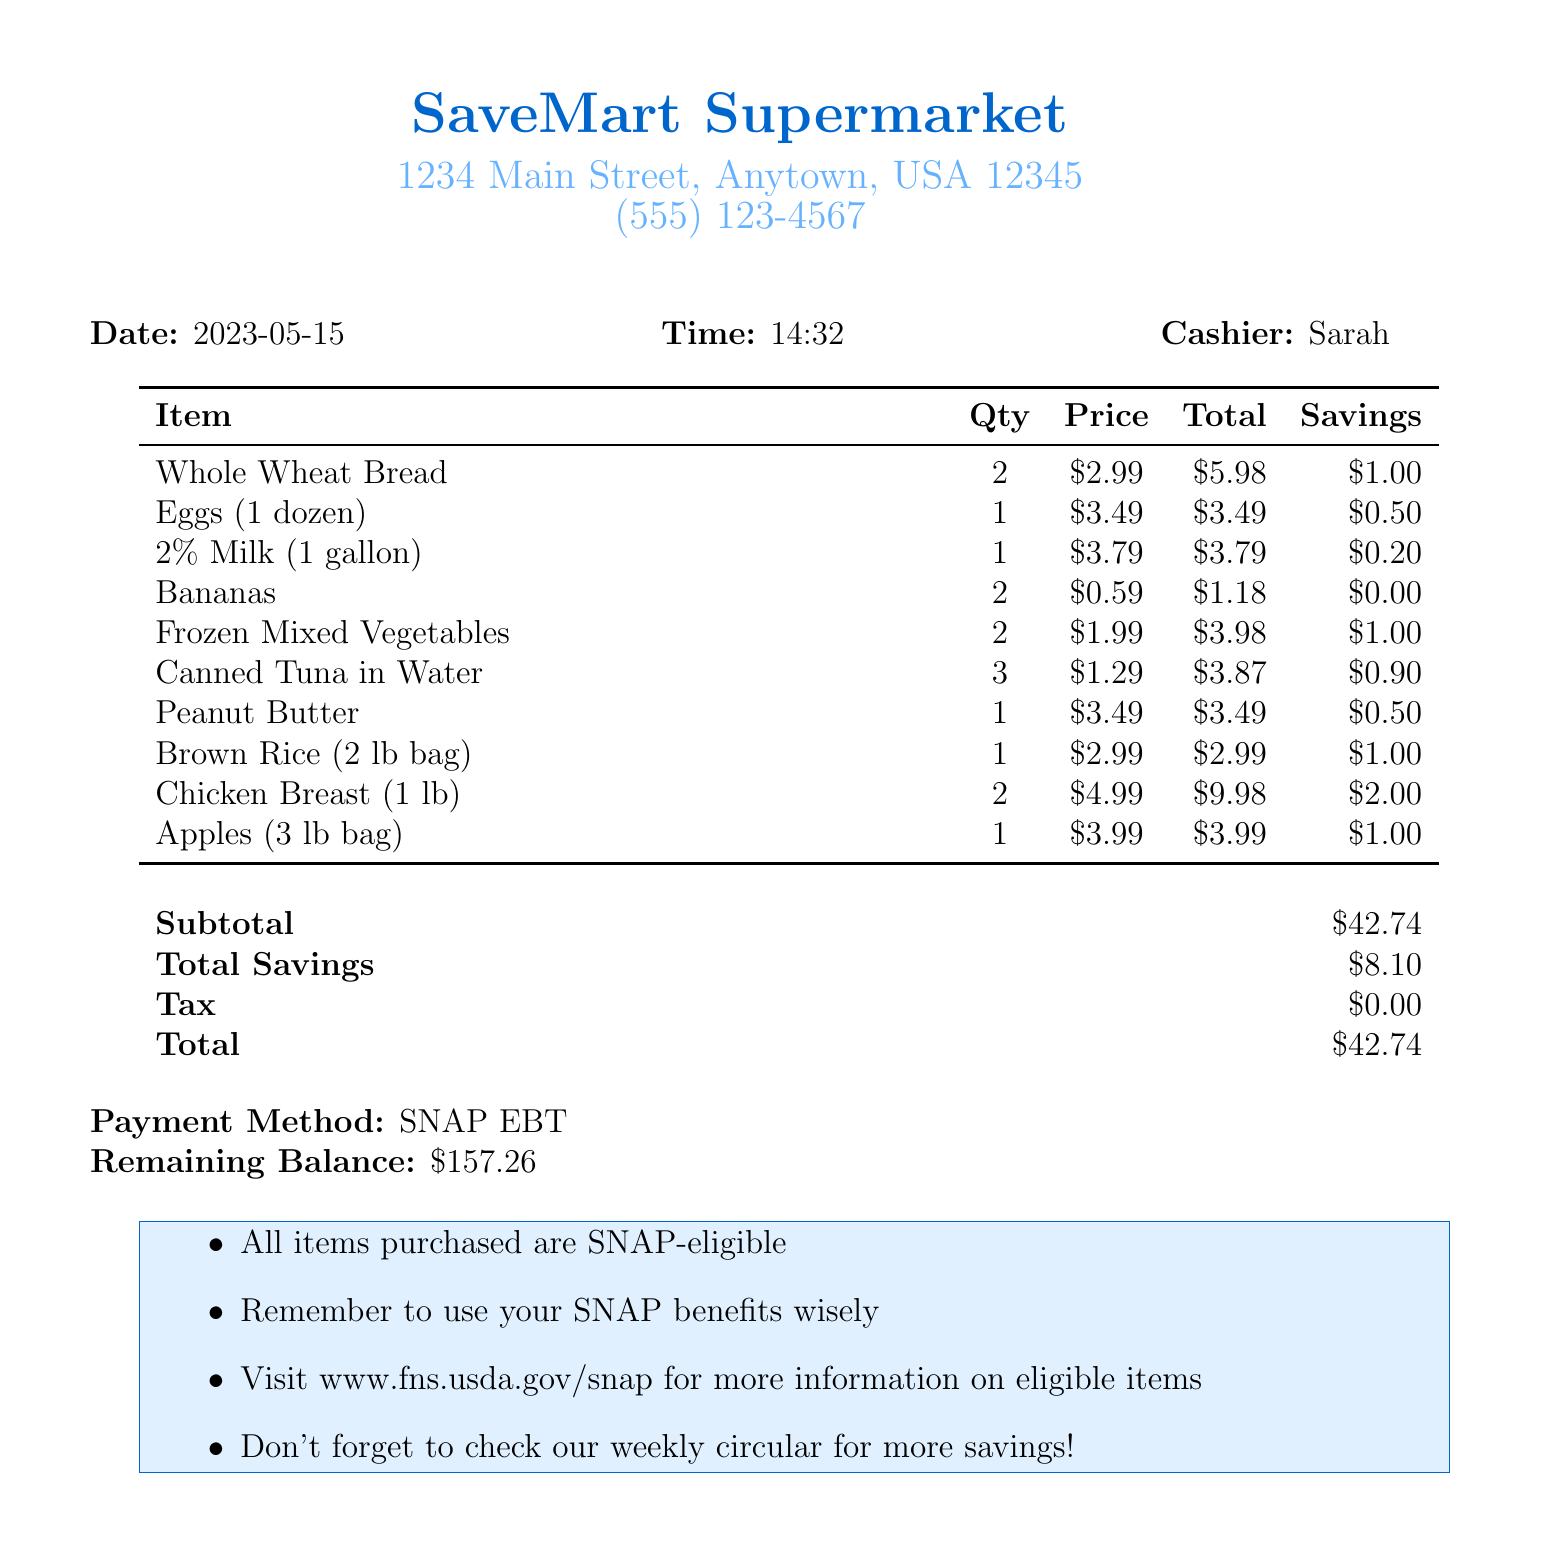What is the name of the store? The name of the store is listed at the top of the invoice.
Answer: SaveMart Supermarket What is the total price of the groceries? The total price is mentioned at the end of the invoice in a specific section.
Answer: $42.74 How much did you save in total? The total savings is detailed towards the end of the invoice.
Answer: $8.10 How many Chicken Breasts did you purchase? The quantity purchased is specified in the itemized list.
Answer: 2 What is the payment method used? The payment method is clearly stated near the bottom of the invoice.
Answer: SNAP EBT What is the price of a dozen Eggs? The price for the eggs is indicated in the itemized section.
Answer: $3.49 How many items are listed in total? Counting the itemized list gives the total number of unique items purchased.
Answer: 10 What is the remaining balance after this transaction? The remaining balance is noted right after the payment method.
Answer: $157.26 What is the address of the store? The address is provided directly beneath the store name.
Answer: 1234 Main Street, Anytown, USA 12345 